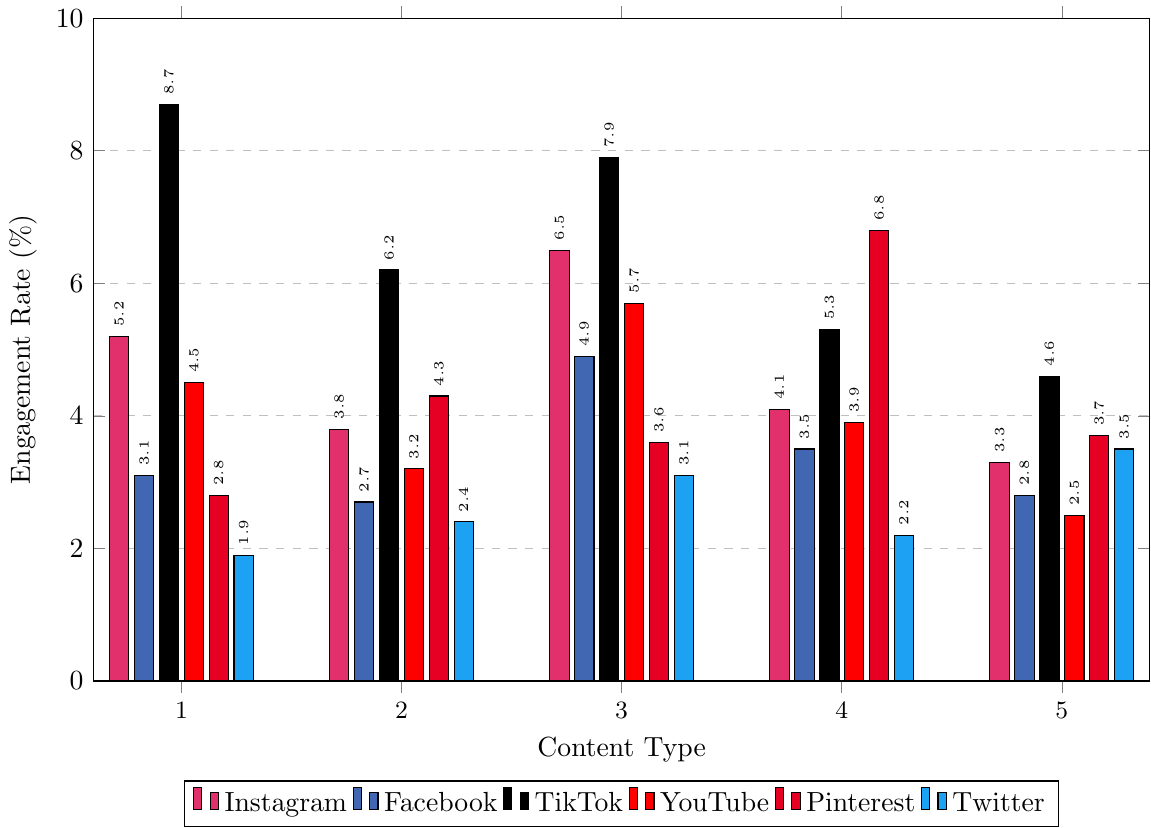Which platform has the highest engagement rate for Workout Videos? By examining the height of the bars in the Workout Videos category, the TikTok bar is the tallest at 8.7%.
Answer: TikTok What is the total engagement rate for Motivational Quotes across all platforms? Total engagement rate is calculated by summing up all engagement rates for Motivational Quotes: Instagram (3.3%) + Facebook (2.8%) + TikTok (4.6%) + YouTube (2.5%) + Pinterest (3.7%) + Twitter (3.5%) = 20.4%.
Answer: 20.4% Which content type shows the highest engagement rate on Pinterest? By comparing the height of the bars under Pinterest, Healthy Recipes has the highest engagement rate at 6.8%.
Answer: Healthy Recipes Is Twitter's engagement rate for Transformation Stories higher or lower than its engagement rate for Healthy Recipes? By comparing the heights of the bars for Twitter, Transformation Stories (3.1%) is higher than Healthy Recipes (2.2%).
Answer: Higher Which platform has the lowest average engagement rate across all content types? Calculate average engagement rate for each platform, then find the minimum: Instagram (4.58), Facebook (3.4), TikTok (6.54), YouTube (3.96), Pinterest (4.24), Twitter (2.62). The lowest is Twitter.
Answer: Twitter What is the difference in engagement rates for Transformation Stories between YouTube and Facebook? Subtract engagement rate of Facebook from YouTube for Transformation Stories: 5.7% - 4.9% = 0.8%.
Answer: 0.8% Compare the visual height representation of fitness content on TikTok and YouTube for Fitness Tips. Which is higher? The Fitness Tips bar for TikTok is higher (6.2%) compared to YouTube (3.2%).
Answer: TikTok What is the engagement rate for Fitness Tips on Pinterest and is it higher or lower than on Facebook? Pinterest’s engagement rate for Fitness Tips is 4.3%, whereas Facebook’s is 2.7%. Pinterest's rate is higher.
Answer: Higher Which content type has the most uniform engagement rate across all platforms? Analyzing the heights of the bars, Motivational Quotes have relatively consistent engagement rates across platforms, with values ranging from 2.5% to 4.6%.
Answer: Motivational Quotes What is the average engagement rate for Healthy Recipes on Instagram and YouTube? Calculate the average: (4.1% + 3.9%) / 2 = 4.0%.
Answer: 4.0% 